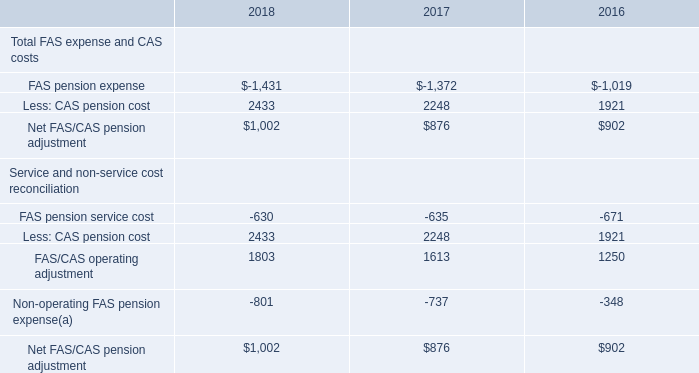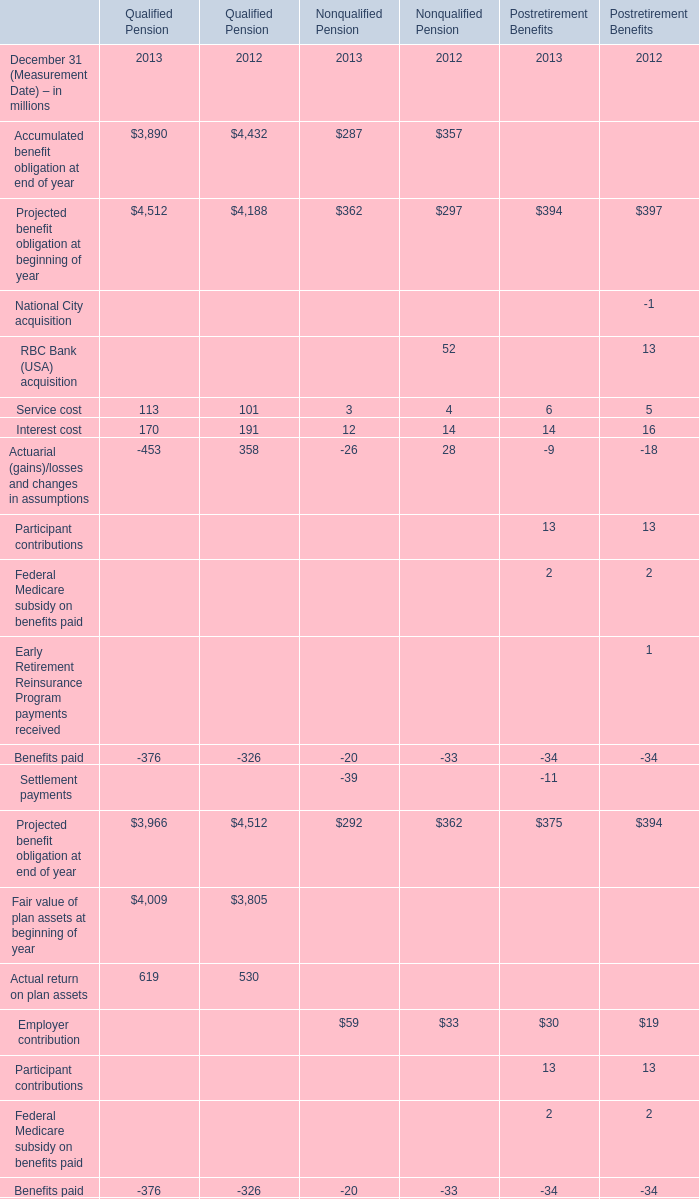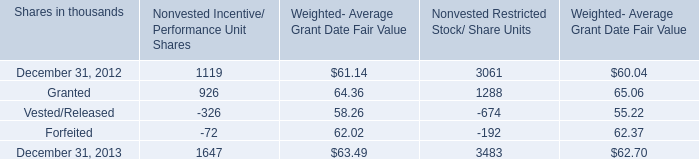what's the total amount of FAS pension expense of 2018, and December 31, 2013 of Nonvested Restricted Stock/ Share Units ? 
Computations: (1431.0 + 3483.0)
Answer: 4914.0. 